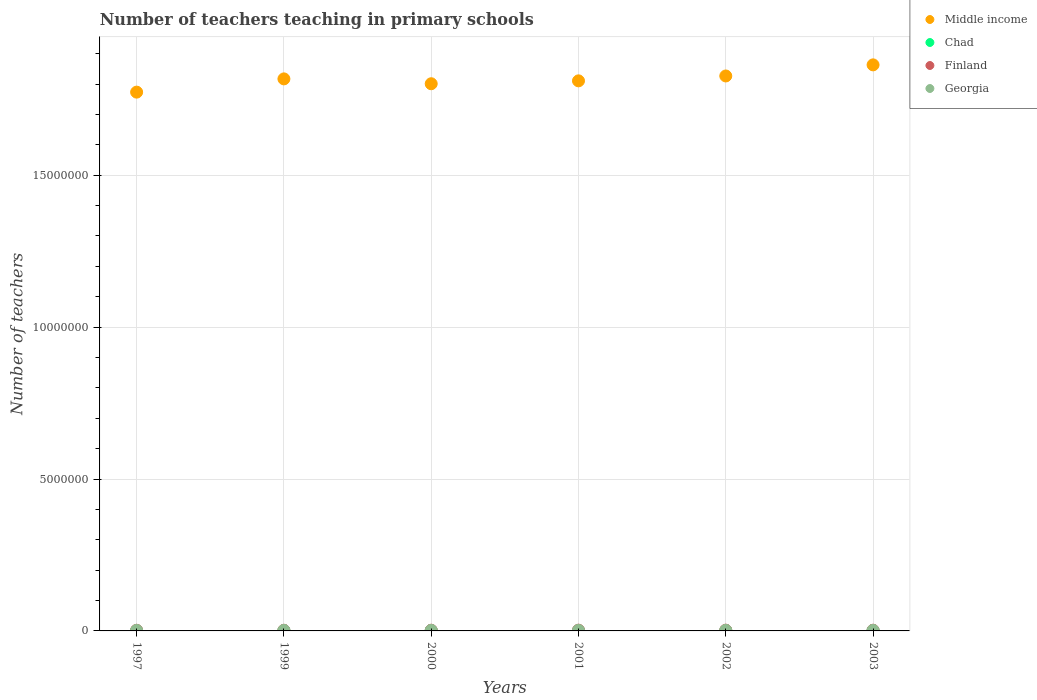How many different coloured dotlines are there?
Ensure brevity in your answer.  4. What is the number of teachers teaching in primary schools in Chad in 2002?
Offer a terse response. 1.60e+04. Across all years, what is the maximum number of teachers teaching in primary schools in Chad?
Keep it short and to the point. 1.61e+04. Across all years, what is the minimum number of teachers teaching in primary schools in Chad?
Your answer should be compact. 1.02e+04. What is the total number of teachers teaching in primary schools in Chad in the graph?
Your response must be concise. 8.18e+04. What is the difference between the number of teachers teaching in primary schools in Middle income in 2002 and that in 2003?
Make the answer very short. -3.66e+05. What is the difference between the number of teachers teaching in primary schools in Finland in 2002 and the number of teachers teaching in primary schools in Middle income in 2001?
Make the answer very short. -1.81e+07. What is the average number of teachers teaching in primary schools in Chad per year?
Your answer should be very brief. 1.36e+04. In the year 1997, what is the difference between the number of teachers teaching in primary schools in Middle income and number of teachers teaching in primary schools in Finland?
Make the answer very short. 1.77e+07. What is the ratio of the number of teachers teaching in primary schools in Middle income in 2001 to that in 2002?
Provide a short and direct response. 0.99. What is the difference between the highest and the second highest number of teachers teaching in primary schools in Middle income?
Keep it short and to the point. 3.66e+05. What is the difference between the highest and the lowest number of teachers teaching in primary schools in Middle income?
Provide a succinct answer. 8.98e+05. In how many years, is the number of teachers teaching in primary schools in Chad greater than the average number of teachers teaching in primary schools in Chad taken over all years?
Keep it short and to the point. 3. Is the sum of the number of teachers teaching in primary schools in Middle income in 1997 and 2003 greater than the maximum number of teachers teaching in primary schools in Georgia across all years?
Give a very brief answer. Yes. Is it the case that in every year, the sum of the number of teachers teaching in primary schools in Georgia and number of teachers teaching in primary schools in Chad  is greater than the sum of number of teachers teaching in primary schools in Middle income and number of teachers teaching in primary schools in Finland?
Your answer should be compact. No. Is it the case that in every year, the sum of the number of teachers teaching in primary schools in Chad and number of teachers teaching in primary schools in Middle income  is greater than the number of teachers teaching in primary schools in Finland?
Your answer should be compact. Yes. How many dotlines are there?
Your response must be concise. 4. How many years are there in the graph?
Offer a terse response. 6. Are the values on the major ticks of Y-axis written in scientific E-notation?
Offer a very short reply. No. Does the graph contain any zero values?
Offer a very short reply. No. Does the graph contain grids?
Your response must be concise. Yes. What is the title of the graph?
Ensure brevity in your answer.  Number of teachers teaching in primary schools. What is the label or title of the X-axis?
Keep it short and to the point. Years. What is the label or title of the Y-axis?
Provide a succinct answer. Number of teachers. What is the Number of teachers in Middle income in 1997?
Make the answer very short. 1.77e+07. What is the Number of teachers of Chad in 1997?
Make the answer very short. 1.02e+04. What is the Number of teachers of Finland in 1997?
Provide a short and direct response. 2.15e+04. What is the Number of teachers in Georgia in 1997?
Give a very brief answer. 1.65e+04. What is the Number of teachers of Middle income in 1999?
Offer a terse response. 1.82e+07. What is the Number of teachers of Chad in 1999?
Your response must be concise. 1.24e+04. What is the Number of teachers in Finland in 1999?
Provide a short and direct response. 2.22e+04. What is the Number of teachers in Georgia in 1999?
Give a very brief answer. 1.74e+04. What is the Number of teachers of Middle income in 2000?
Keep it short and to the point. 1.80e+07. What is the Number of teachers of Chad in 2000?
Provide a short and direct response. 1.33e+04. What is the Number of teachers in Finland in 2000?
Provide a short and direct response. 2.33e+04. What is the Number of teachers of Georgia in 2000?
Keep it short and to the point. 1.77e+04. What is the Number of teachers of Middle income in 2001?
Your answer should be compact. 1.81e+07. What is the Number of teachers of Chad in 2001?
Give a very brief answer. 1.38e+04. What is the Number of teachers in Finland in 2001?
Ensure brevity in your answer.  2.47e+04. What is the Number of teachers of Georgia in 2001?
Make the answer very short. 1.77e+04. What is the Number of teachers of Middle income in 2002?
Keep it short and to the point. 1.83e+07. What is the Number of teachers of Chad in 2002?
Your answer should be very brief. 1.60e+04. What is the Number of teachers of Finland in 2002?
Offer a terse response. 2.53e+04. What is the Number of teachers in Georgia in 2002?
Your response must be concise. 1.84e+04. What is the Number of teachers in Middle income in 2003?
Provide a short and direct response. 1.86e+07. What is the Number of teachers in Chad in 2003?
Offer a terse response. 1.61e+04. What is the Number of teachers in Finland in 2003?
Your response must be concise. 2.40e+04. What is the Number of teachers of Georgia in 2003?
Make the answer very short. 1.65e+04. Across all years, what is the maximum Number of teachers in Middle income?
Ensure brevity in your answer.  1.86e+07. Across all years, what is the maximum Number of teachers of Chad?
Keep it short and to the point. 1.61e+04. Across all years, what is the maximum Number of teachers in Finland?
Give a very brief answer. 2.53e+04. Across all years, what is the maximum Number of teachers in Georgia?
Ensure brevity in your answer.  1.84e+04. Across all years, what is the minimum Number of teachers of Middle income?
Your response must be concise. 1.77e+07. Across all years, what is the minimum Number of teachers of Chad?
Your response must be concise. 1.02e+04. Across all years, what is the minimum Number of teachers of Finland?
Make the answer very short. 2.15e+04. Across all years, what is the minimum Number of teachers of Georgia?
Offer a very short reply. 1.65e+04. What is the total Number of teachers of Middle income in the graph?
Give a very brief answer. 1.09e+08. What is the total Number of teachers in Chad in the graph?
Keep it short and to the point. 8.18e+04. What is the total Number of teachers of Finland in the graph?
Provide a succinct answer. 1.41e+05. What is the total Number of teachers in Georgia in the graph?
Offer a very short reply. 1.04e+05. What is the difference between the Number of teachers of Middle income in 1997 and that in 1999?
Your answer should be very brief. -4.36e+05. What is the difference between the Number of teachers in Chad in 1997 and that in 1999?
Keep it short and to the point. -2222. What is the difference between the Number of teachers of Finland in 1997 and that in 1999?
Provide a succinct answer. -704. What is the difference between the Number of teachers in Georgia in 1997 and that in 1999?
Ensure brevity in your answer.  -823. What is the difference between the Number of teachers in Middle income in 1997 and that in 2000?
Offer a terse response. -2.76e+05. What is the difference between the Number of teachers in Chad in 1997 and that in 2000?
Your answer should be very brief. -3162. What is the difference between the Number of teachers in Finland in 1997 and that in 2000?
Your answer should be compact. -1796. What is the difference between the Number of teachers in Georgia in 1997 and that in 2000?
Provide a short and direct response. -1172. What is the difference between the Number of teachers in Middle income in 1997 and that in 2001?
Offer a terse response. -3.72e+05. What is the difference between the Number of teachers of Chad in 1997 and that in 2001?
Provide a short and direct response. -3668. What is the difference between the Number of teachers in Finland in 1997 and that in 2001?
Provide a short and direct response. -3210. What is the difference between the Number of teachers of Georgia in 1997 and that in 2001?
Offer a terse response. -1190. What is the difference between the Number of teachers of Middle income in 1997 and that in 2002?
Offer a terse response. -5.32e+05. What is the difference between the Number of teachers in Chad in 1997 and that in 2002?
Offer a terse response. -5820. What is the difference between the Number of teachers of Finland in 1997 and that in 2002?
Ensure brevity in your answer.  -3801. What is the difference between the Number of teachers of Georgia in 1997 and that in 2002?
Keep it short and to the point. -1864. What is the difference between the Number of teachers of Middle income in 1997 and that in 2003?
Make the answer very short. -8.98e+05. What is the difference between the Number of teachers of Chad in 1997 and that in 2003?
Keep it short and to the point. -5991. What is the difference between the Number of teachers in Finland in 1997 and that in 2003?
Provide a short and direct response. -2565. What is the difference between the Number of teachers in Georgia in 1997 and that in 2003?
Keep it short and to the point. 42. What is the difference between the Number of teachers of Middle income in 1999 and that in 2000?
Offer a terse response. 1.60e+05. What is the difference between the Number of teachers in Chad in 1999 and that in 2000?
Make the answer very short. -940. What is the difference between the Number of teachers in Finland in 1999 and that in 2000?
Provide a short and direct response. -1092. What is the difference between the Number of teachers in Georgia in 1999 and that in 2000?
Keep it short and to the point. -349. What is the difference between the Number of teachers in Middle income in 1999 and that in 2001?
Your answer should be very brief. 6.46e+04. What is the difference between the Number of teachers in Chad in 1999 and that in 2001?
Provide a succinct answer. -1446. What is the difference between the Number of teachers of Finland in 1999 and that in 2001?
Provide a short and direct response. -2506. What is the difference between the Number of teachers in Georgia in 1999 and that in 2001?
Make the answer very short. -367. What is the difference between the Number of teachers in Middle income in 1999 and that in 2002?
Your answer should be compact. -9.60e+04. What is the difference between the Number of teachers in Chad in 1999 and that in 2002?
Ensure brevity in your answer.  -3598. What is the difference between the Number of teachers in Finland in 1999 and that in 2002?
Keep it short and to the point. -3097. What is the difference between the Number of teachers of Georgia in 1999 and that in 2002?
Offer a very short reply. -1041. What is the difference between the Number of teachers of Middle income in 1999 and that in 2003?
Provide a succinct answer. -4.62e+05. What is the difference between the Number of teachers of Chad in 1999 and that in 2003?
Your response must be concise. -3769. What is the difference between the Number of teachers in Finland in 1999 and that in 2003?
Provide a succinct answer. -1861. What is the difference between the Number of teachers of Georgia in 1999 and that in 2003?
Your answer should be compact. 865. What is the difference between the Number of teachers in Middle income in 2000 and that in 2001?
Make the answer very short. -9.53e+04. What is the difference between the Number of teachers in Chad in 2000 and that in 2001?
Your answer should be very brief. -506. What is the difference between the Number of teachers of Finland in 2000 and that in 2001?
Provide a succinct answer. -1414. What is the difference between the Number of teachers of Middle income in 2000 and that in 2002?
Your answer should be compact. -2.56e+05. What is the difference between the Number of teachers of Chad in 2000 and that in 2002?
Offer a terse response. -2658. What is the difference between the Number of teachers of Finland in 2000 and that in 2002?
Provide a succinct answer. -2005. What is the difference between the Number of teachers in Georgia in 2000 and that in 2002?
Your answer should be very brief. -692. What is the difference between the Number of teachers of Middle income in 2000 and that in 2003?
Make the answer very short. -6.21e+05. What is the difference between the Number of teachers in Chad in 2000 and that in 2003?
Offer a terse response. -2829. What is the difference between the Number of teachers in Finland in 2000 and that in 2003?
Make the answer very short. -769. What is the difference between the Number of teachers of Georgia in 2000 and that in 2003?
Ensure brevity in your answer.  1214. What is the difference between the Number of teachers of Middle income in 2001 and that in 2002?
Provide a short and direct response. -1.61e+05. What is the difference between the Number of teachers of Chad in 2001 and that in 2002?
Offer a very short reply. -2152. What is the difference between the Number of teachers in Finland in 2001 and that in 2002?
Your response must be concise. -591. What is the difference between the Number of teachers in Georgia in 2001 and that in 2002?
Offer a very short reply. -674. What is the difference between the Number of teachers of Middle income in 2001 and that in 2003?
Offer a terse response. -5.26e+05. What is the difference between the Number of teachers in Chad in 2001 and that in 2003?
Make the answer very short. -2323. What is the difference between the Number of teachers of Finland in 2001 and that in 2003?
Your answer should be very brief. 645. What is the difference between the Number of teachers in Georgia in 2001 and that in 2003?
Your response must be concise. 1232. What is the difference between the Number of teachers of Middle income in 2002 and that in 2003?
Your response must be concise. -3.66e+05. What is the difference between the Number of teachers in Chad in 2002 and that in 2003?
Provide a short and direct response. -171. What is the difference between the Number of teachers of Finland in 2002 and that in 2003?
Offer a very short reply. 1236. What is the difference between the Number of teachers of Georgia in 2002 and that in 2003?
Offer a terse response. 1906. What is the difference between the Number of teachers of Middle income in 1997 and the Number of teachers of Chad in 1999?
Your answer should be very brief. 1.77e+07. What is the difference between the Number of teachers in Middle income in 1997 and the Number of teachers in Finland in 1999?
Your answer should be compact. 1.77e+07. What is the difference between the Number of teachers of Middle income in 1997 and the Number of teachers of Georgia in 1999?
Offer a terse response. 1.77e+07. What is the difference between the Number of teachers of Chad in 1997 and the Number of teachers of Finland in 1999?
Ensure brevity in your answer.  -1.20e+04. What is the difference between the Number of teachers in Chad in 1997 and the Number of teachers in Georgia in 1999?
Your answer should be very brief. -7214. What is the difference between the Number of teachers in Finland in 1997 and the Number of teachers in Georgia in 1999?
Your response must be concise. 4094. What is the difference between the Number of teachers in Middle income in 1997 and the Number of teachers in Chad in 2000?
Your answer should be compact. 1.77e+07. What is the difference between the Number of teachers in Middle income in 1997 and the Number of teachers in Finland in 2000?
Make the answer very short. 1.77e+07. What is the difference between the Number of teachers in Middle income in 1997 and the Number of teachers in Georgia in 2000?
Provide a short and direct response. 1.77e+07. What is the difference between the Number of teachers in Chad in 1997 and the Number of teachers in Finland in 2000?
Offer a very short reply. -1.31e+04. What is the difference between the Number of teachers of Chad in 1997 and the Number of teachers of Georgia in 2000?
Make the answer very short. -7563. What is the difference between the Number of teachers in Finland in 1997 and the Number of teachers in Georgia in 2000?
Ensure brevity in your answer.  3745. What is the difference between the Number of teachers in Middle income in 1997 and the Number of teachers in Chad in 2001?
Your answer should be compact. 1.77e+07. What is the difference between the Number of teachers in Middle income in 1997 and the Number of teachers in Finland in 2001?
Ensure brevity in your answer.  1.77e+07. What is the difference between the Number of teachers of Middle income in 1997 and the Number of teachers of Georgia in 2001?
Provide a succinct answer. 1.77e+07. What is the difference between the Number of teachers of Chad in 1997 and the Number of teachers of Finland in 2001?
Give a very brief answer. -1.45e+04. What is the difference between the Number of teachers of Chad in 1997 and the Number of teachers of Georgia in 2001?
Keep it short and to the point. -7581. What is the difference between the Number of teachers in Finland in 1997 and the Number of teachers in Georgia in 2001?
Offer a terse response. 3727. What is the difference between the Number of teachers in Middle income in 1997 and the Number of teachers in Chad in 2002?
Your response must be concise. 1.77e+07. What is the difference between the Number of teachers of Middle income in 1997 and the Number of teachers of Finland in 2002?
Your answer should be compact. 1.77e+07. What is the difference between the Number of teachers in Middle income in 1997 and the Number of teachers in Georgia in 2002?
Provide a succinct answer. 1.77e+07. What is the difference between the Number of teachers of Chad in 1997 and the Number of teachers of Finland in 2002?
Provide a succinct answer. -1.51e+04. What is the difference between the Number of teachers in Chad in 1997 and the Number of teachers in Georgia in 2002?
Your answer should be compact. -8255. What is the difference between the Number of teachers in Finland in 1997 and the Number of teachers in Georgia in 2002?
Keep it short and to the point. 3053. What is the difference between the Number of teachers in Middle income in 1997 and the Number of teachers in Chad in 2003?
Offer a very short reply. 1.77e+07. What is the difference between the Number of teachers of Middle income in 1997 and the Number of teachers of Finland in 2003?
Give a very brief answer. 1.77e+07. What is the difference between the Number of teachers in Middle income in 1997 and the Number of teachers in Georgia in 2003?
Provide a short and direct response. 1.77e+07. What is the difference between the Number of teachers in Chad in 1997 and the Number of teachers in Finland in 2003?
Make the answer very short. -1.39e+04. What is the difference between the Number of teachers in Chad in 1997 and the Number of teachers in Georgia in 2003?
Provide a short and direct response. -6349. What is the difference between the Number of teachers of Finland in 1997 and the Number of teachers of Georgia in 2003?
Provide a succinct answer. 4959. What is the difference between the Number of teachers of Middle income in 1999 and the Number of teachers of Chad in 2000?
Make the answer very short. 1.82e+07. What is the difference between the Number of teachers of Middle income in 1999 and the Number of teachers of Finland in 2000?
Keep it short and to the point. 1.81e+07. What is the difference between the Number of teachers of Middle income in 1999 and the Number of teachers of Georgia in 2000?
Your response must be concise. 1.82e+07. What is the difference between the Number of teachers of Chad in 1999 and the Number of teachers of Finland in 2000?
Your answer should be compact. -1.09e+04. What is the difference between the Number of teachers of Chad in 1999 and the Number of teachers of Georgia in 2000?
Keep it short and to the point. -5341. What is the difference between the Number of teachers of Finland in 1999 and the Number of teachers of Georgia in 2000?
Your answer should be compact. 4449. What is the difference between the Number of teachers in Middle income in 1999 and the Number of teachers in Chad in 2001?
Make the answer very short. 1.82e+07. What is the difference between the Number of teachers of Middle income in 1999 and the Number of teachers of Finland in 2001?
Give a very brief answer. 1.81e+07. What is the difference between the Number of teachers of Middle income in 1999 and the Number of teachers of Georgia in 2001?
Your answer should be compact. 1.82e+07. What is the difference between the Number of teachers of Chad in 1999 and the Number of teachers of Finland in 2001?
Keep it short and to the point. -1.23e+04. What is the difference between the Number of teachers in Chad in 1999 and the Number of teachers in Georgia in 2001?
Give a very brief answer. -5359. What is the difference between the Number of teachers in Finland in 1999 and the Number of teachers in Georgia in 2001?
Provide a short and direct response. 4431. What is the difference between the Number of teachers in Middle income in 1999 and the Number of teachers in Chad in 2002?
Provide a short and direct response. 1.82e+07. What is the difference between the Number of teachers in Middle income in 1999 and the Number of teachers in Finland in 2002?
Make the answer very short. 1.81e+07. What is the difference between the Number of teachers in Middle income in 1999 and the Number of teachers in Georgia in 2002?
Your response must be concise. 1.82e+07. What is the difference between the Number of teachers in Chad in 1999 and the Number of teachers in Finland in 2002?
Your answer should be very brief. -1.29e+04. What is the difference between the Number of teachers in Chad in 1999 and the Number of teachers in Georgia in 2002?
Keep it short and to the point. -6033. What is the difference between the Number of teachers in Finland in 1999 and the Number of teachers in Georgia in 2002?
Your answer should be compact. 3757. What is the difference between the Number of teachers in Middle income in 1999 and the Number of teachers in Chad in 2003?
Your answer should be compact. 1.82e+07. What is the difference between the Number of teachers in Middle income in 1999 and the Number of teachers in Finland in 2003?
Your answer should be compact. 1.81e+07. What is the difference between the Number of teachers of Middle income in 1999 and the Number of teachers of Georgia in 2003?
Keep it short and to the point. 1.82e+07. What is the difference between the Number of teachers in Chad in 1999 and the Number of teachers in Finland in 2003?
Your answer should be very brief. -1.17e+04. What is the difference between the Number of teachers in Chad in 1999 and the Number of teachers in Georgia in 2003?
Your answer should be compact. -4127. What is the difference between the Number of teachers in Finland in 1999 and the Number of teachers in Georgia in 2003?
Offer a very short reply. 5663. What is the difference between the Number of teachers in Middle income in 2000 and the Number of teachers in Chad in 2001?
Provide a short and direct response. 1.80e+07. What is the difference between the Number of teachers of Middle income in 2000 and the Number of teachers of Finland in 2001?
Your response must be concise. 1.80e+07. What is the difference between the Number of teachers in Middle income in 2000 and the Number of teachers in Georgia in 2001?
Provide a short and direct response. 1.80e+07. What is the difference between the Number of teachers in Chad in 2000 and the Number of teachers in Finland in 2001?
Provide a short and direct response. -1.14e+04. What is the difference between the Number of teachers in Chad in 2000 and the Number of teachers in Georgia in 2001?
Provide a succinct answer. -4419. What is the difference between the Number of teachers of Finland in 2000 and the Number of teachers of Georgia in 2001?
Ensure brevity in your answer.  5523. What is the difference between the Number of teachers in Middle income in 2000 and the Number of teachers in Chad in 2002?
Keep it short and to the point. 1.80e+07. What is the difference between the Number of teachers of Middle income in 2000 and the Number of teachers of Finland in 2002?
Offer a terse response. 1.80e+07. What is the difference between the Number of teachers of Middle income in 2000 and the Number of teachers of Georgia in 2002?
Ensure brevity in your answer.  1.80e+07. What is the difference between the Number of teachers of Chad in 2000 and the Number of teachers of Finland in 2002?
Your answer should be compact. -1.19e+04. What is the difference between the Number of teachers of Chad in 2000 and the Number of teachers of Georgia in 2002?
Ensure brevity in your answer.  -5093. What is the difference between the Number of teachers of Finland in 2000 and the Number of teachers of Georgia in 2002?
Your response must be concise. 4849. What is the difference between the Number of teachers in Middle income in 2000 and the Number of teachers in Chad in 2003?
Offer a terse response. 1.80e+07. What is the difference between the Number of teachers of Middle income in 2000 and the Number of teachers of Finland in 2003?
Make the answer very short. 1.80e+07. What is the difference between the Number of teachers in Middle income in 2000 and the Number of teachers in Georgia in 2003?
Provide a succinct answer. 1.80e+07. What is the difference between the Number of teachers in Chad in 2000 and the Number of teachers in Finland in 2003?
Make the answer very short. -1.07e+04. What is the difference between the Number of teachers in Chad in 2000 and the Number of teachers in Georgia in 2003?
Ensure brevity in your answer.  -3187. What is the difference between the Number of teachers of Finland in 2000 and the Number of teachers of Georgia in 2003?
Provide a short and direct response. 6755. What is the difference between the Number of teachers of Middle income in 2001 and the Number of teachers of Chad in 2002?
Make the answer very short. 1.81e+07. What is the difference between the Number of teachers of Middle income in 2001 and the Number of teachers of Finland in 2002?
Offer a very short reply. 1.81e+07. What is the difference between the Number of teachers of Middle income in 2001 and the Number of teachers of Georgia in 2002?
Your answer should be compact. 1.81e+07. What is the difference between the Number of teachers of Chad in 2001 and the Number of teachers of Finland in 2002?
Provide a short and direct response. -1.14e+04. What is the difference between the Number of teachers of Chad in 2001 and the Number of teachers of Georgia in 2002?
Keep it short and to the point. -4587. What is the difference between the Number of teachers of Finland in 2001 and the Number of teachers of Georgia in 2002?
Make the answer very short. 6263. What is the difference between the Number of teachers of Middle income in 2001 and the Number of teachers of Chad in 2003?
Offer a very short reply. 1.81e+07. What is the difference between the Number of teachers in Middle income in 2001 and the Number of teachers in Finland in 2003?
Provide a succinct answer. 1.81e+07. What is the difference between the Number of teachers in Middle income in 2001 and the Number of teachers in Georgia in 2003?
Provide a succinct answer. 1.81e+07. What is the difference between the Number of teachers of Chad in 2001 and the Number of teachers of Finland in 2003?
Ensure brevity in your answer.  -1.02e+04. What is the difference between the Number of teachers in Chad in 2001 and the Number of teachers in Georgia in 2003?
Make the answer very short. -2681. What is the difference between the Number of teachers of Finland in 2001 and the Number of teachers of Georgia in 2003?
Ensure brevity in your answer.  8169. What is the difference between the Number of teachers in Middle income in 2002 and the Number of teachers in Chad in 2003?
Provide a succinct answer. 1.83e+07. What is the difference between the Number of teachers in Middle income in 2002 and the Number of teachers in Finland in 2003?
Offer a very short reply. 1.82e+07. What is the difference between the Number of teachers in Middle income in 2002 and the Number of teachers in Georgia in 2003?
Make the answer very short. 1.83e+07. What is the difference between the Number of teachers in Chad in 2002 and the Number of teachers in Finland in 2003?
Your answer should be very brief. -8053. What is the difference between the Number of teachers in Chad in 2002 and the Number of teachers in Georgia in 2003?
Offer a terse response. -529. What is the difference between the Number of teachers in Finland in 2002 and the Number of teachers in Georgia in 2003?
Make the answer very short. 8760. What is the average Number of teachers in Middle income per year?
Provide a succinct answer. 1.82e+07. What is the average Number of teachers in Chad per year?
Your answer should be compact. 1.36e+04. What is the average Number of teachers of Finland per year?
Offer a terse response. 2.35e+04. What is the average Number of teachers of Georgia per year?
Make the answer very short. 1.74e+04. In the year 1997, what is the difference between the Number of teachers of Middle income and Number of teachers of Chad?
Keep it short and to the point. 1.77e+07. In the year 1997, what is the difference between the Number of teachers in Middle income and Number of teachers in Finland?
Offer a very short reply. 1.77e+07. In the year 1997, what is the difference between the Number of teachers in Middle income and Number of teachers in Georgia?
Give a very brief answer. 1.77e+07. In the year 1997, what is the difference between the Number of teachers in Chad and Number of teachers in Finland?
Provide a short and direct response. -1.13e+04. In the year 1997, what is the difference between the Number of teachers in Chad and Number of teachers in Georgia?
Your response must be concise. -6391. In the year 1997, what is the difference between the Number of teachers in Finland and Number of teachers in Georgia?
Offer a terse response. 4917. In the year 1999, what is the difference between the Number of teachers of Middle income and Number of teachers of Chad?
Ensure brevity in your answer.  1.82e+07. In the year 1999, what is the difference between the Number of teachers in Middle income and Number of teachers in Finland?
Your answer should be very brief. 1.81e+07. In the year 1999, what is the difference between the Number of teachers in Middle income and Number of teachers in Georgia?
Ensure brevity in your answer.  1.82e+07. In the year 1999, what is the difference between the Number of teachers of Chad and Number of teachers of Finland?
Offer a very short reply. -9790. In the year 1999, what is the difference between the Number of teachers in Chad and Number of teachers in Georgia?
Provide a short and direct response. -4992. In the year 1999, what is the difference between the Number of teachers of Finland and Number of teachers of Georgia?
Make the answer very short. 4798. In the year 2000, what is the difference between the Number of teachers of Middle income and Number of teachers of Chad?
Make the answer very short. 1.80e+07. In the year 2000, what is the difference between the Number of teachers of Middle income and Number of teachers of Finland?
Ensure brevity in your answer.  1.80e+07. In the year 2000, what is the difference between the Number of teachers of Middle income and Number of teachers of Georgia?
Your answer should be very brief. 1.80e+07. In the year 2000, what is the difference between the Number of teachers in Chad and Number of teachers in Finland?
Give a very brief answer. -9942. In the year 2000, what is the difference between the Number of teachers of Chad and Number of teachers of Georgia?
Make the answer very short. -4401. In the year 2000, what is the difference between the Number of teachers of Finland and Number of teachers of Georgia?
Your answer should be very brief. 5541. In the year 2001, what is the difference between the Number of teachers of Middle income and Number of teachers of Chad?
Your answer should be very brief. 1.81e+07. In the year 2001, what is the difference between the Number of teachers in Middle income and Number of teachers in Finland?
Your answer should be very brief. 1.81e+07. In the year 2001, what is the difference between the Number of teachers in Middle income and Number of teachers in Georgia?
Provide a short and direct response. 1.81e+07. In the year 2001, what is the difference between the Number of teachers of Chad and Number of teachers of Finland?
Keep it short and to the point. -1.08e+04. In the year 2001, what is the difference between the Number of teachers of Chad and Number of teachers of Georgia?
Your response must be concise. -3913. In the year 2001, what is the difference between the Number of teachers of Finland and Number of teachers of Georgia?
Your answer should be compact. 6937. In the year 2002, what is the difference between the Number of teachers in Middle income and Number of teachers in Chad?
Offer a terse response. 1.83e+07. In the year 2002, what is the difference between the Number of teachers in Middle income and Number of teachers in Finland?
Your answer should be compact. 1.82e+07. In the year 2002, what is the difference between the Number of teachers of Middle income and Number of teachers of Georgia?
Ensure brevity in your answer.  1.82e+07. In the year 2002, what is the difference between the Number of teachers in Chad and Number of teachers in Finland?
Provide a short and direct response. -9289. In the year 2002, what is the difference between the Number of teachers of Chad and Number of teachers of Georgia?
Your answer should be very brief. -2435. In the year 2002, what is the difference between the Number of teachers of Finland and Number of teachers of Georgia?
Your response must be concise. 6854. In the year 2003, what is the difference between the Number of teachers of Middle income and Number of teachers of Chad?
Your answer should be very brief. 1.86e+07. In the year 2003, what is the difference between the Number of teachers in Middle income and Number of teachers in Finland?
Make the answer very short. 1.86e+07. In the year 2003, what is the difference between the Number of teachers in Middle income and Number of teachers in Georgia?
Offer a terse response. 1.86e+07. In the year 2003, what is the difference between the Number of teachers of Chad and Number of teachers of Finland?
Provide a short and direct response. -7882. In the year 2003, what is the difference between the Number of teachers of Chad and Number of teachers of Georgia?
Provide a succinct answer. -358. In the year 2003, what is the difference between the Number of teachers in Finland and Number of teachers in Georgia?
Provide a succinct answer. 7524. What is the ratio of the Number of teachers of Chad in 1997 to that in 1999?
Keep it short and to the point. 0.82. What is the ratio of the Number of teachers in Finland in 1997 to that in 1999?
Provide a short and direct response. 0.97. What is the ratio of the Number of teachers in Georgia in 1997 to that in 1999?
Your answer should be very brief. 0.95. What is the ratio of the Number of teachers of Middle income in 1997 to that in 2000?
Ensure brevity in your answer.  0.98. What is the ratio of the Number of teachers in Chad in 1997 to that in 2000?
Ensure brevity in your answer.  0.76. What is the ratio of the Number of teachers in Finland in 1997 to that in 2000?
Offer a terse response. 0.92. What is the ratio of the Number of teachers in Georgia in 1997 to that in 2000?
Your answer should be compact. 0.93. What is the ratio of the Number of teachers of Middle income in 1997 to that in 2001?
Ensure brevity in your answer.  0.98. What is the ratio of the Number of teachers in Chad in 1997 to that in 2001?
Your answer should be very brief. 0.73. What is the ratio of the Number of teachers in Finland in 1997 to that in 2001?
Ensure brevity in your answer.  0.87. What is the ratio of the Number of teachers in Georgia in 1997 to that in 2001?
Your answer should be very brief. 0.93. What is the ratio of the Number of teachers in Middle income in 1997 to that in 2002?
Ensure brevity in your answer.  0.97. What is the ratio of the Number of teachers in Chad in 1997 to that in 2002?
Your answer should be compact. 0.64. What is the ratio of the Number of teachers in Finland in 1997 to that in 2002?
Your response must be concise. 0.85. What is the ratio of the Number of teachers in Georgia in 1997 to that in 2002?
Your response must be concise. 0.9. What is the ratio of the Number of teachers of Middle income in 1997 to that in 2003?
Provide a short and direct response. 0.95. What is the ratio of the Number of teachers in Chad in 1997 to that in 2003?
Keep it short and to the point. 0.63. What is the ratio of the Number of teachers of Finland in 1997 to that in 2003?
Offer a very short reply. 0.89. What is the ratio of the Number of teachers in Georgia in 1997 to that in 2003?
Offer a terse response. 1. What is the ratio of the Number of teachers of Middle income in 1999 to that in 2000?
Your response must be concise. 1.01. What is the ratio of the Number of teachers of Chad in 1999 to that in 2000?
Offer a terse response. 0.93. What is the ratio of the Number of teachers of Finland in 1999 to that in 2000?
Provide a short and direct response. 0.95. What is the ratio of the Number of teachers in Georgia in 1999 to that in 2000?
Ensure brevity in your answer.  0.98. What is the ratio of the Number of teachers in Chad in 1999 to that in 2001?
Offer a very short reply. 0.9. What is the ratio of the Number of teachers in Finland in 1999 to that in 2001?
Your response must be concise. 0.9. What is the ratio of the Number of teachers in Georgia in 1999 to that in 2001?
Your response must be concise. 0.98. What is the ratio of the Number of teachers in Chad in 1999 to that in 2002?
Your answer should be compact. 0.77. What is the ratio of the Number of teachers of Finland in 1999 to that in 2002?
Offer a terse response. 0.88. What is the ratio of the Number of teachers of Georgia in 1999 to that in 2002?
Your response must be concise. 0.94. What is the ratio of the Number of teachers in Middle income in 1999 to that in 2003?
Your answer should be compact. 0.98. What is the ratio of the Number of teachers in Chad in 1999 to that in 2003?
Provide a succinct answer. 0.77. What is the ratio of the Number of teachers of Finland in 1999 to that in 2003?
Give a very brief answer. 0.92. What is the ratio of the Number of teachers of Georgia in 1999 to that in 2003?
Offer a terse response. 1.05. What is the ratio of the Number of teachers of Middle income in 2000 to that in 2001?
Give a very brief answer. 0.99. What is the ratio of the Number of teachers in Chad in 2000 to that in 2001?
Offer a very short reply. 0.96. What is the ratio of the Number of teachers of Finland in 2000 to that in 2001?
Offer a very short reply. 0.94. What is the ratio of the Number of teachers of Georgia in 2000 to that in 2001?
Your answer should be very brief. 1. What is the ratio of the Number of teachers in Middle income in 2000 to that in 2002?
Offer a terse response. 0.99. What is the ratio of the Number of teachers in Chad in 2000 to that in 2002?
Your response must be concise. 0.83. What is the ratio of the Number of teachers of Finland in 2000 to that in 2002?
Give a very brief answer. 0.92. What is the ratio of the Number of teachers in Georgia in 2000 to that in 2002?
Keep it short and to the point. 0.96. What is the ratio of the Number of teachers of Middle income in 2000 to that in 2003?
Keep it short and to the point. 0.97. What is the ratio of the Number of teachers in Chad in 2000 to that in 2003?
Your response must be concise. 0.82. What is the ratio of the Number of teachers of Georgia in 2000 to that in 2003?
Your answer should be compact. 1.07. What is the ratio of the Number of teachers in Chad in 2001 to that in 2002?
Make the answer very short. 0.87. What is the ratio of the Number of teachers in Finland in 2001 to that in 2002?
Offer a terse response. 0.98. What is the ratio of the Number of teachers of Georgia in 2001 to that in 2002?
Your response must be concise. 0.96. What is the ratio of the Number of teachers in Middle income in 2001 to that in 2003?
Your response must be concise. 0.97. What is the ratio of the Number of teachers of Chad in 2001 to that in 2003?
Your answer should be very brief. 0.86. What is the ratio of the Number of teachers of Finland in 2001 to that in 2003?
Your answer should be very brief. 1.03. What is the ratio of the Number of teachers of Georgia in 2001 to that in 2003?
Make the answer very short. 1.07. What is the ratio of the Number of teachers in Middle income in 2002 to that in 2003?
Keep it short and to the point. 0.98. What is the ratio of the Number of teachers in Chad in 2002 to that in 2003?
Provide a short and direct response. 0.99. What is the ratio of the Number of teachers in Finland in 2002 to that in 2003?
Your answer should be compact. 1.05. What is the ratio of the Number of teachers of Georgia in 2002 to that in 2003?
Provide a succinct answer. 1.12. What is the difference between the highest and the second highest Number of teachers in Middle income?
Offer a very short reply. 3.66e+05. What is the difference between the highest and the second highest Number of teachers in Chad?
Ensure brevity in your answer.  171. What is the difference between the highest and the second highest Number of teachers of Finland?
Your response must be concise. 591. What is the difference between the highest and the second highest Number of teachers of Georgia?
Provide a short and direct response. 674. What is the difference between the highest and the lowest Number of teachers in Middle income?
Your answer should be compact. 8.98e+05. What is the difference between the highest and the lowest Number of teachers in Chad?
Make the answer very short. 5991. What is the difference between the highest and the lowest Number of teachers of Finland?
Provide a succinct answer. 3801. What is the difference between the highest and the lowest Number of teachers of Georgia?
Provide a short and direct response. 1906. 